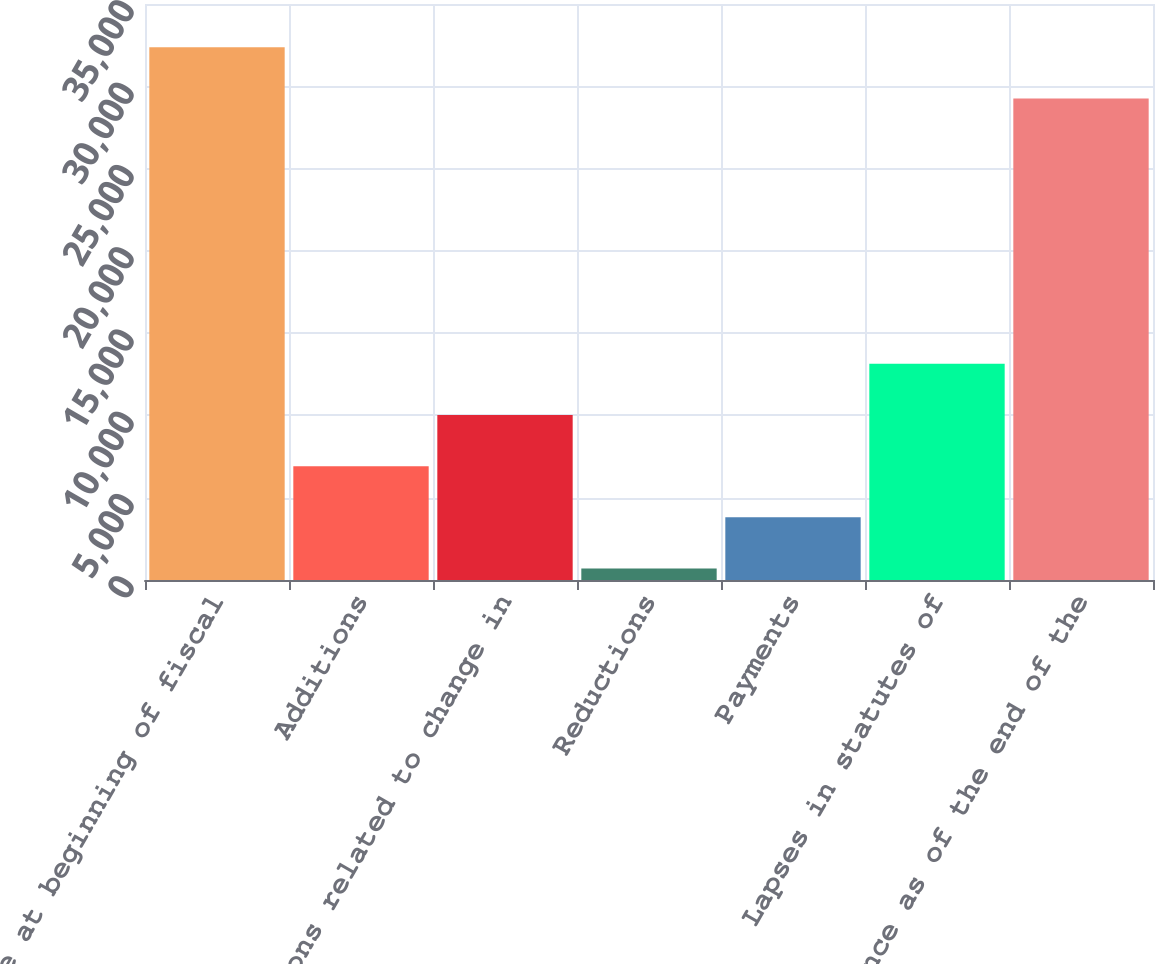Convert chart to OTSL. <chart><loc_0><loc_0><loc_500><loc_500><bar_chart><fcel>Balance at beginning of fiscal<fcel>Additions<fcel>Additions related to change in<fcel>Reductions<fcel>Payments<fcel>Lapses in statutes of<fcel>Balance as of the end of the<nl><fcel>32368<fcel>6918<fcel>10027<fcel>700<fcel>3809<fcel>13136<fcel>29259<nl></chart> 